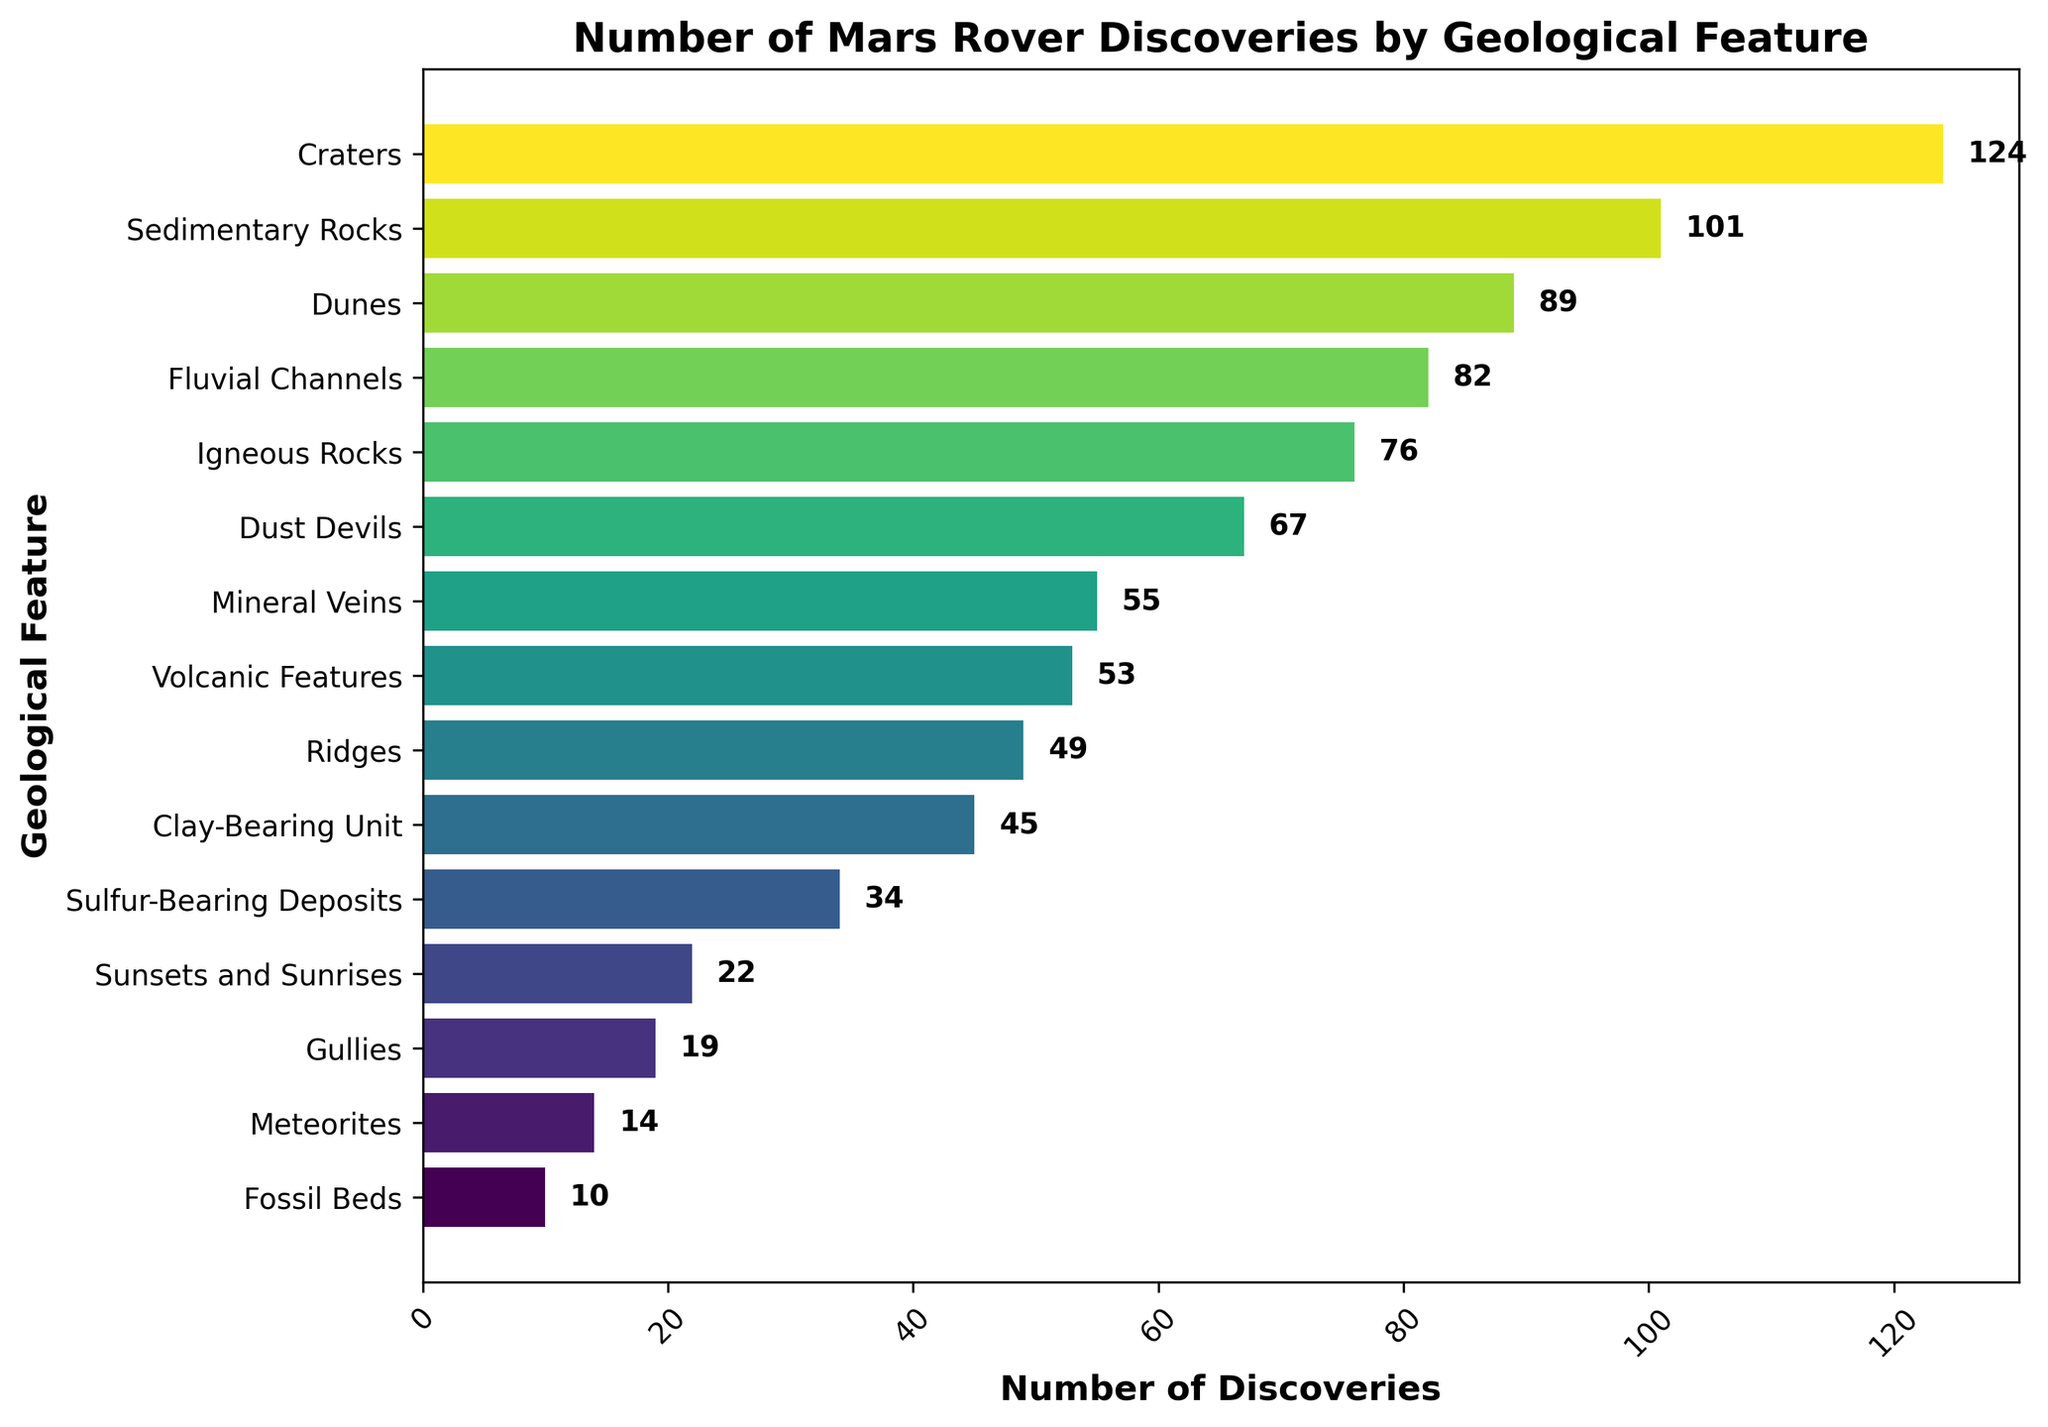Which geological feature has the highest number of discoveries? By observing the figure, the geological feature with the longest bar represents the highest number of discoveries. The bar for Craters is the longest.
Answer: Craters Which geological feature has the lowest number of discoveries? The geological feature with the shortest bar in the figure represents the lowest number of discoveries. The bar for Fossil Beds is the shortest.
Answer: Fossil Beds How many more discoveries are there in Craters compared to Volcanic Features? From the figure, Craters have 124 discoveries and Volcanic Features have 53 discoveries. Subtracting these gives 124 - 53 = 71.
Answer: 71 What's the average number of discoveries for the top three geological features? The top three geological features by number of discoveries are Craters (124), Sedimentary Rocks (101), and Dunes (89). Adding their discoveries and dividing by 3 gives (124 + 101 + 89) / 3 = 314 / 3 ≈ 104.67.
Answer: 104.67 Which geological features have discoveries less than 50? By observing the lengths of the bars, the geological features with bars shorter than 50 are: Sulfur-Bearing Deposits, Clay-Bearing Unit, Sunsets and Sunrises, Fossil Beds, Gullies, and Meteorites.
Answer: Sulfur-Bearing Deposits, Clay-Bearing Unit, Sunsets and Sunrises, Fossil Beds, Gullies, Meteorites How many geological features have more than 60 discoveries? By observing the figure, the bars representing more than 60 discoveries are for Craters, Dunes, Sedimentary Rocks, Dust Devils, and Fluvial Channels. There are 5 such features.
Answer: 5 Which geological feature has exactly 45 discoveries? Observing the figure, the bar for Clay-Bearing Unit lines up exactly with the 45 mark.
Answer: Clay-Bearing Unit How many discoveries are there in total for Craters, Dunes, and Sedimentary Rocks combined? Adding the number of discoveries for Craters (124), Dunes (89), and Sedimentary Rocks (101) gives 124 + 89 + 101 = 314.
Answer: 314 What is the difference in the number of discoveries between Fluvial Channels and Gullies? By observing the figure, Fluvial Channels have 82 discoveries and Gullies have 19. Subtracting these gives 82 - 19 = 63.
Answer: 63 